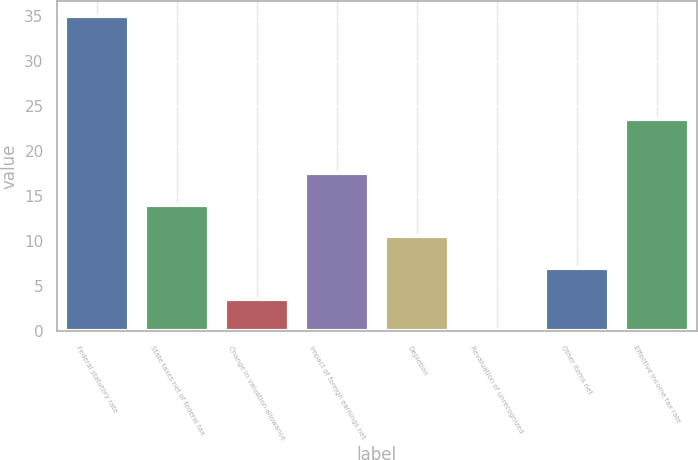<chart> <loc_0><loc_0><loc_500><loc_500><bar_chart><fcel>Federal statutory rate<fcel>State taxes net of federal tax<fcel>Change in valuation allowance<fcel>Impact of foreign earnings net<fcel>Depletion<fcel>Revaluation of unrecognized<fcel>Other items net<fcel>Effective income tax rate<nl><fcel>35<fcel>14.06<fcel>3.59<fcel>17.55<fcel>10.57<fcel>0.1<fcel>7.08<fcel>23.6<nl></chart> 